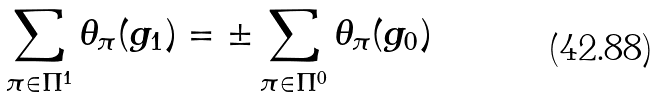<formula> <loc_0><loc_0><loc_500><loc_500>\sum _ { \pi \in \Pi ^ { 1 } } \theta _ { \pi } ( g _ { 1 } ) = \pm \sum _ { \pi \in \Pi ^ { 0 } } \theta _ { \pi } ( g _ { 0 } )</formula> 